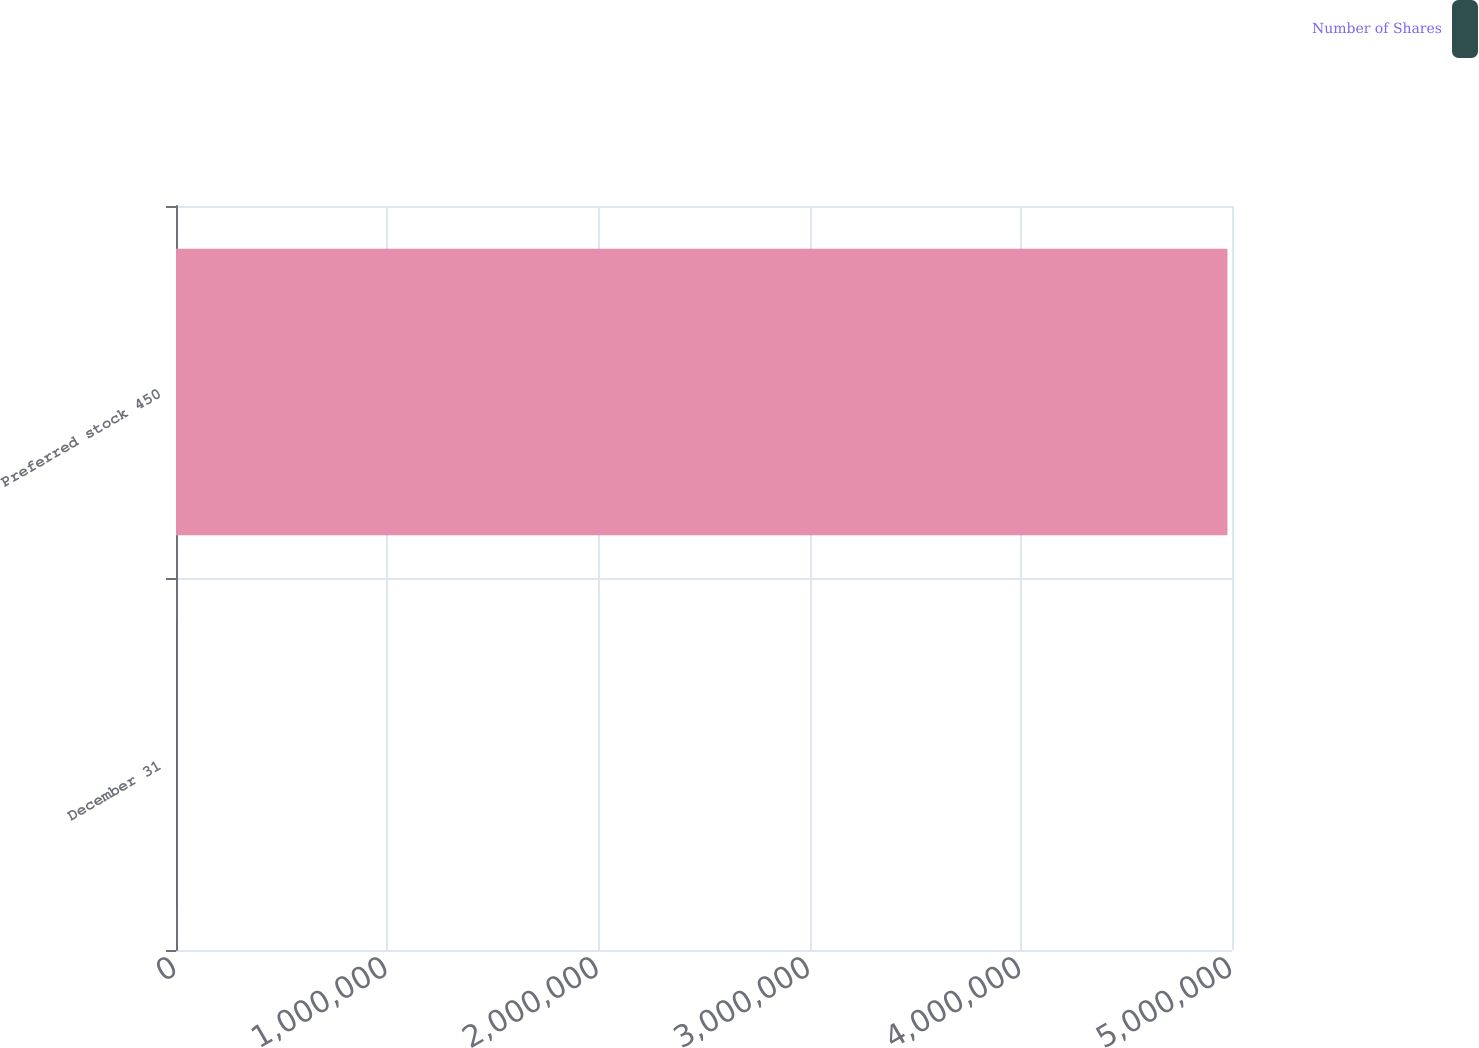Convert chart to OTSL. <chart><loc_0><loc_0><loc_500><loc_500><stacked_bar_chart><ecel><fcel>December 31<fcel>Preferred stock 450<nl><fcel>nan<fcel>2008<fcel>4.978e+06<nl><fcel>Number of Shares<fcel>2008<fcel>249<nl></chart> 